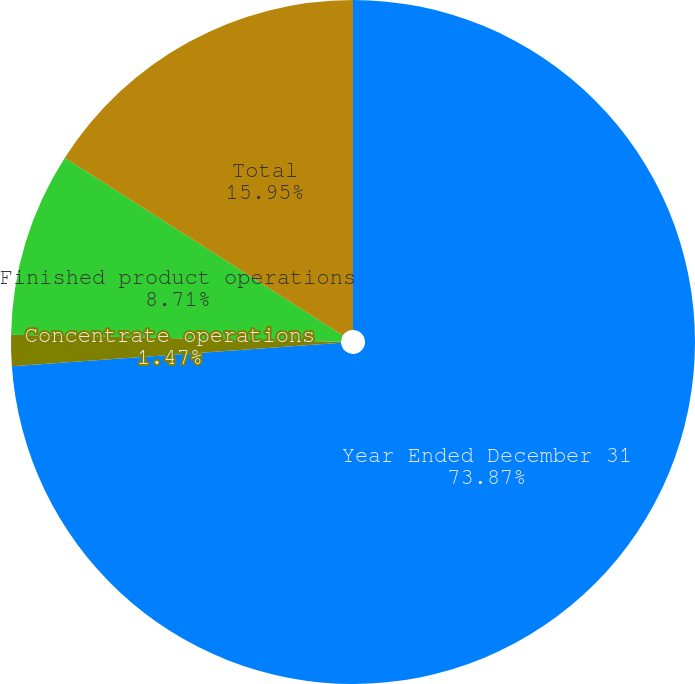Convert chart to OTSL. <chart><loc_0><loc_0><loc_500><loc_500><pie_chart><fcel>Year Ended December 31<fcel>Concentrate operations<fcel>Finished product operations<fcel>Total<nl><fcel>73.88%<fcel>1.47%<fcel>8.71%<fcel>15.95%<nl></chart> 